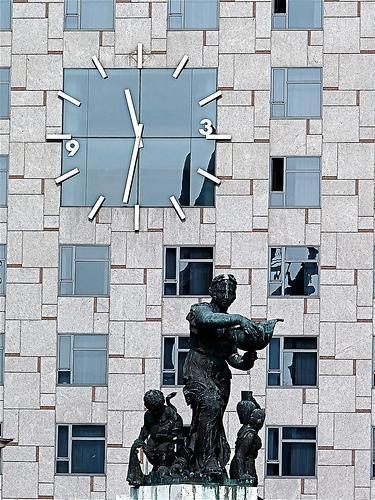How many figures are in the statue?
Give a very brief answer. 3. 